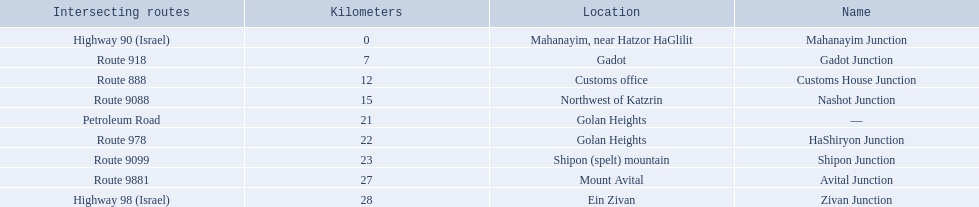Which junctions are located on numbered routes, and not highways or other types? Gadot Junction, Customs House Junction, Nashot Junction, HaShiryon Junction, Shipon Junction, Avital Junction. Of these junctions, which ones are located on routes with four digits (ex. route 9999)? Nashot Junction, Shipon Junction, Avital Junction. Of the remaining routes, which is located on shipon (spelt) mountain? Shipon Junction. 